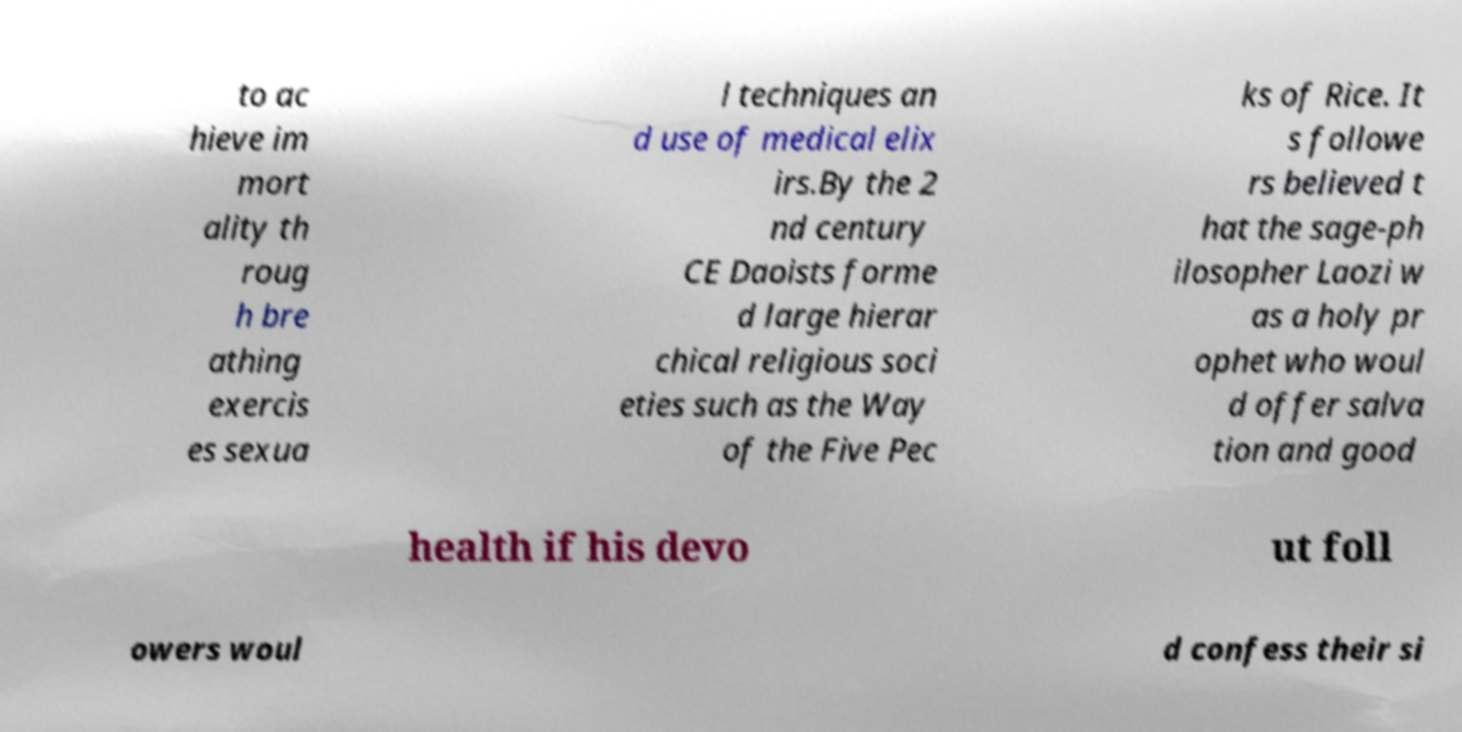For documentation purposes, I need the text within this image transcribed. Could you provide that? to ac hieve im mort ality th roug h bre athing exercis es sexua l techniques an d use of medical elix irs.By the 2 nd century CE Daoists forme d large hierar chical religious soci eties such as the Way of the Five Pec ks of Rice. It s followe rs believed t hat the sage-ph ilosopher Laozi w as a holy pr ophet who woul d offer salva tion and good health if his devo ut foll owers woul d confess their si 